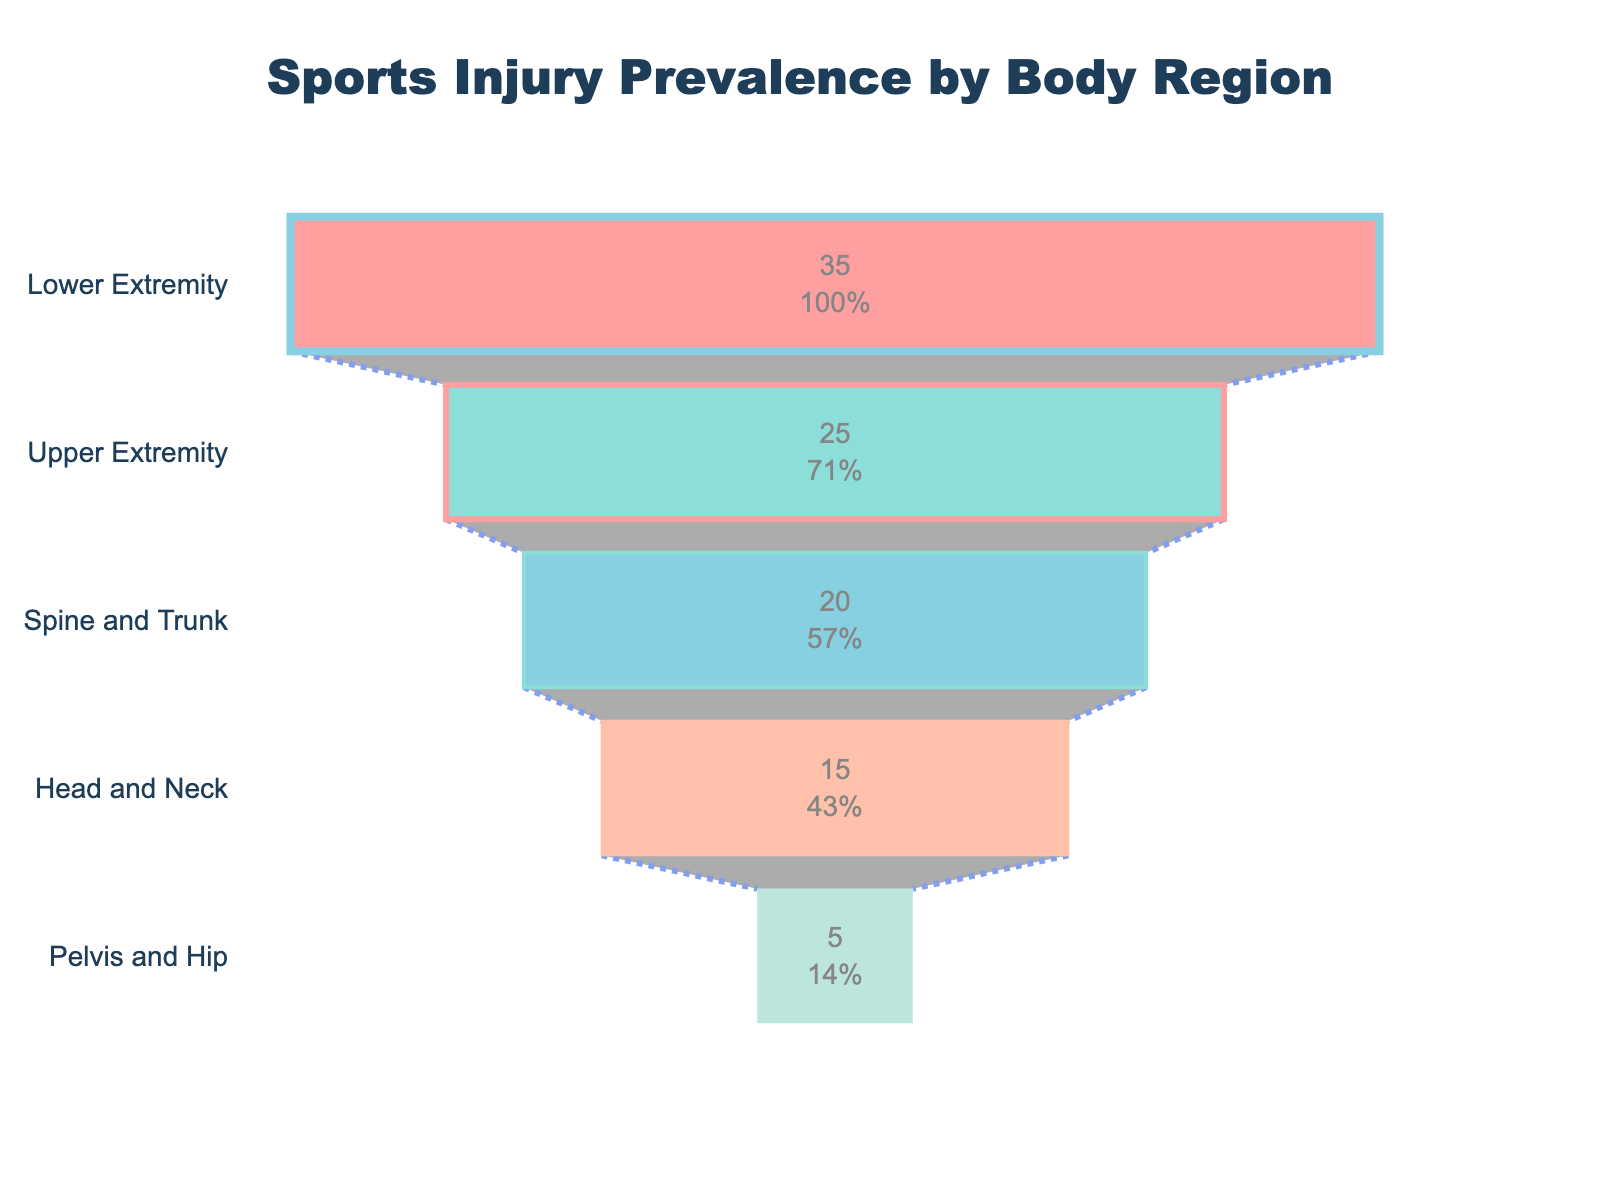What's the title of this chart? The title is usually displayed at the top of the chart. In this case, the title is "Sports Injury Prevalence by Body Region."
Answer: Sports Injury Prevalence by Body Region Which body region has the highest prevalence of sports injuries? The funnel chart ranks body regions by injury prevalence from top to bottom, with the topmost region having the highest prevalence. The topmost region here is the Lower Extremity.
Answer: Lower Extremity Which body region has the lowest prevalence of sports injuries? The bottom of the funnel chart signifies the region with the lowest prevalence. Here, the lowest is the Pelvis and Hip.
Answer: Pelvis and Hip What is the injury prevalence percentage of the Upper Extremity compared to the total? The funnel chart typically provides the prevalence value as a percentage of the total; in this case, it's shown inside the section for Upper Extremity. The value for Upper Extremity is seen as 25%.
Answer: 25% How many percentage points lower is the prevalence of Spine and Trunk injuries compared to Lower Extremity injuries? Lower Extremity has 35% prevalence, and Spine and Trunk has 20%. The difference in percentage points is 35% - 20%.
Answer: 15% What's the injury prevalence of the Lower Extremity and Upper Extremity combined? The values for Lower Extremity and Upper Extremity are provided, which are 35 and 25, respectively. Their combined prevalence is 35 + 25.
Answer: 60 Which color is used to represent injury prevalence in the Spine and Trunk region? Each body region is represented by different colors in the chart. Spine and Trunk is in the middle of the funnel and uses a light blue color.
Answer: Light blue What is the total prevalence of injuries across all body regions? Add the provided prevalence values for all body regions: 35 (Lower Extremity) + 25 (Upper Extremity) + 20 (Spine and Trunk) + 15 (Head and Neck) + 5 (Pelvis and Hip). This gives us the total prevalence.
Answer: 100 By how many percentage points does the Upper Extremity differ from the Head and Neck in terms of injury prevalence? The funnel chart provides prevalence values for each region. Upper Extremity is 25%, and Head and Neck is 15%. The difference between them is 25% - 15%.
Answer: 10 Which body region shows a stronger contrast in color at the border, and why might this be significant? In the funnel chart, the line width indicates the contrast. Lower Extremity has the thickest border, which makes it stand out and signifies high prevalence.
Answer: Lower Extremity 